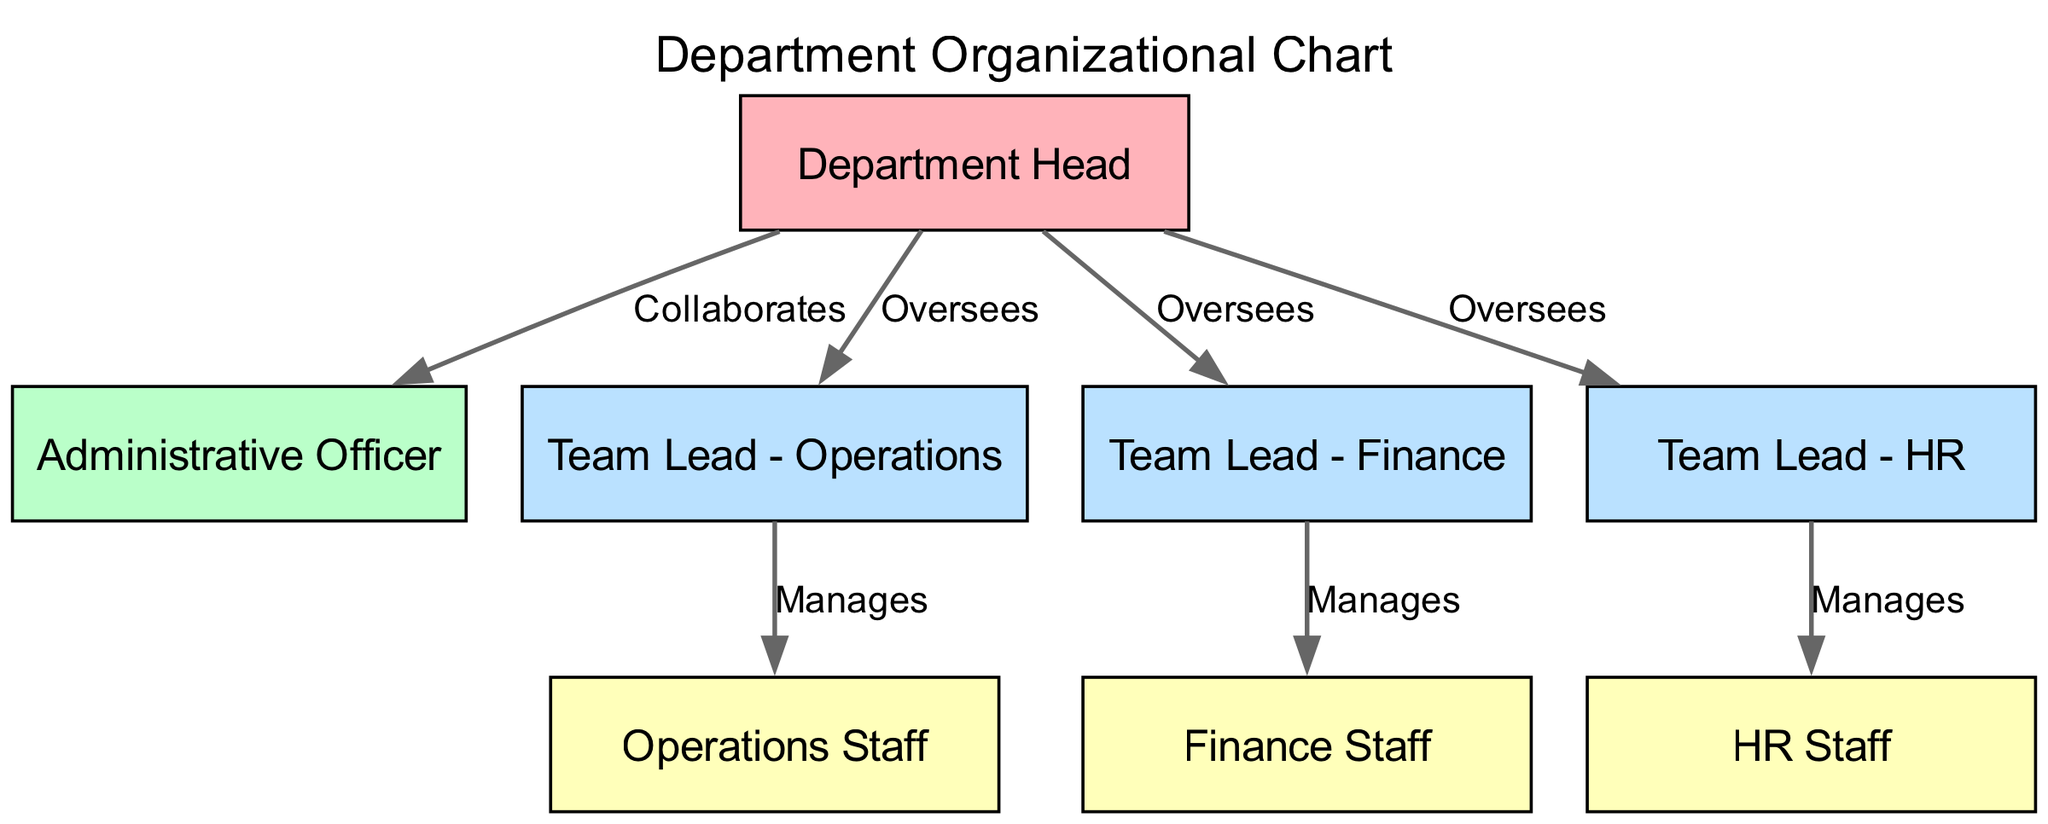What is the title of the diagram? The title of the diagram is provided in the "title" field of the data, which indicates what the diagram represents. Thus, the title is "Department Organizational Chart".
Answer: Department Organizational Chart How many nodes are there in the diagram? To find the number of nodes, we can count all entries in the "nodes" array from the data. There are 8 entries, which correspond to the different roles in the department structure.
Answer: 8 Who does the Administrative Officer report to? The relationship is specified in the "edges" array where the edge from the Department Head to the Administrative Officer is labeled as "Collaborates". This indicates that the Administrative Officer reports to the Department Head.
Answer: Department Head What is the lowest level in the hierarchy? The levels are defined in the "level" attribute for each node. The lowest level is level 4, which includes the Operations Staff, Finance Staff, and HR Staff.
Answer: 4 How many teams does the Department Head oversee? The Department Head has edges that indicate oversight over three different Team Leads: Team Lead - Operations, Team Lead - Finance, and Team Lead - HR. Counting these edges gives a total of three teams.
Answer: 3 Who manages the HR Staff? The "edges" array indicates a direct relationship where the HR Staff is managed by the Team Lead - HR, as shown by the edge from Team Lead - HR to HR Staff, labeled "Manages".
Answer: Team Lead - HR What is the relationship between the Team Lead - Operations and the Operations Staff? Based on the edges, the relationship is that the Team Lead - Operations manages the Operations Staff, as indicated by the edge connecting these two nodes with the label "Manages".
Answer: Manages Which role has the highest level in the hierarchy? By inspecting the "level" attributes, the role with the highest level, indicated by the smallest number, is the Department Head, which has the level 1.
Answer: Department Head 